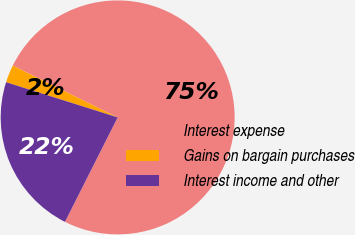Convert chart to OTSL. <chart><loc_0><loc_0><loc_500><loc_500><pie_chart><fcel>Interest expense<fcel>Gains on bargain purchases<fcel>Interest income and other<nl><fcel>75.13%<fcel>2.44%<fcel>22.43%<nl></chart> 